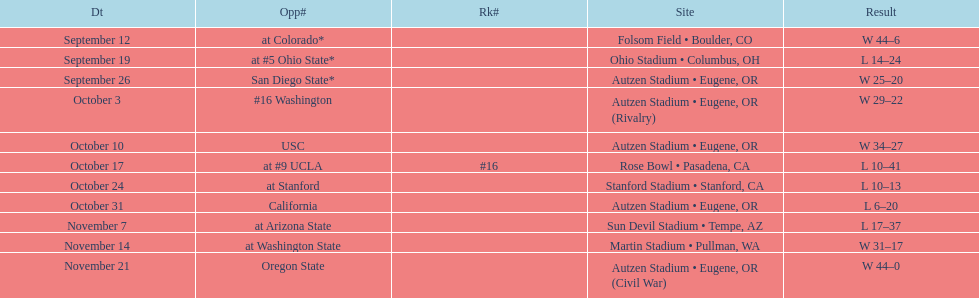How many games did the team win while not at home? 2. 